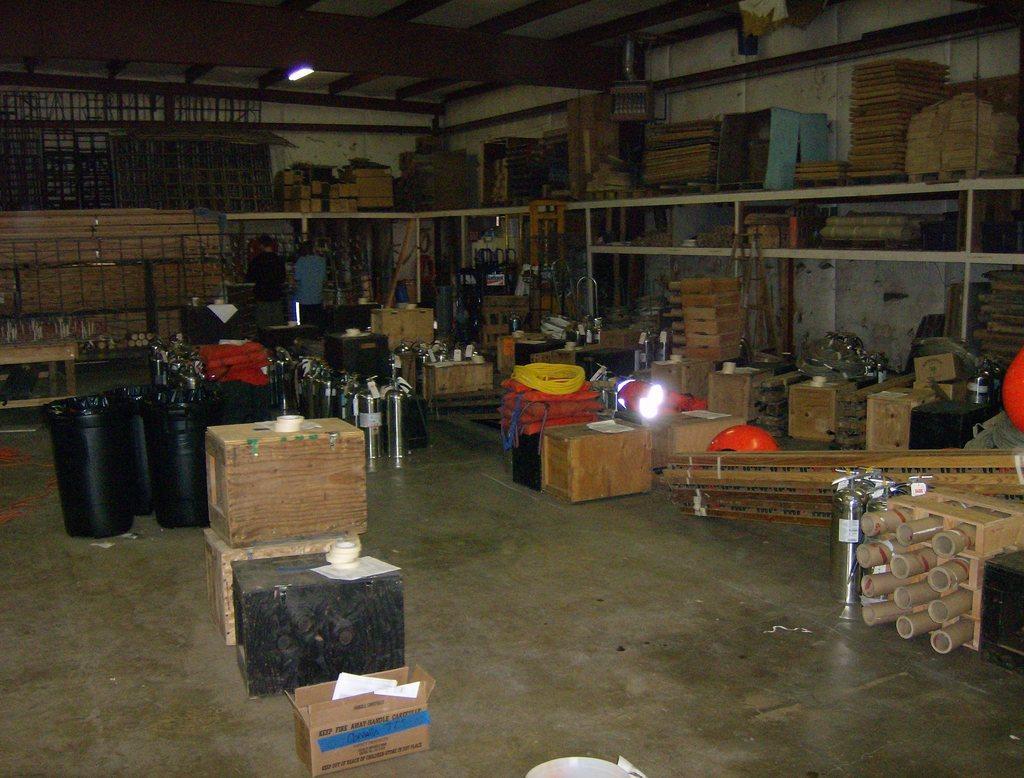Can you describe this image briefly? In this image we can see so many different objects are arranged on racks and on the floor. In the background, we can see two people are standing. At the top of the image, there is the roof with light. There is a grille in the left top of the image. 